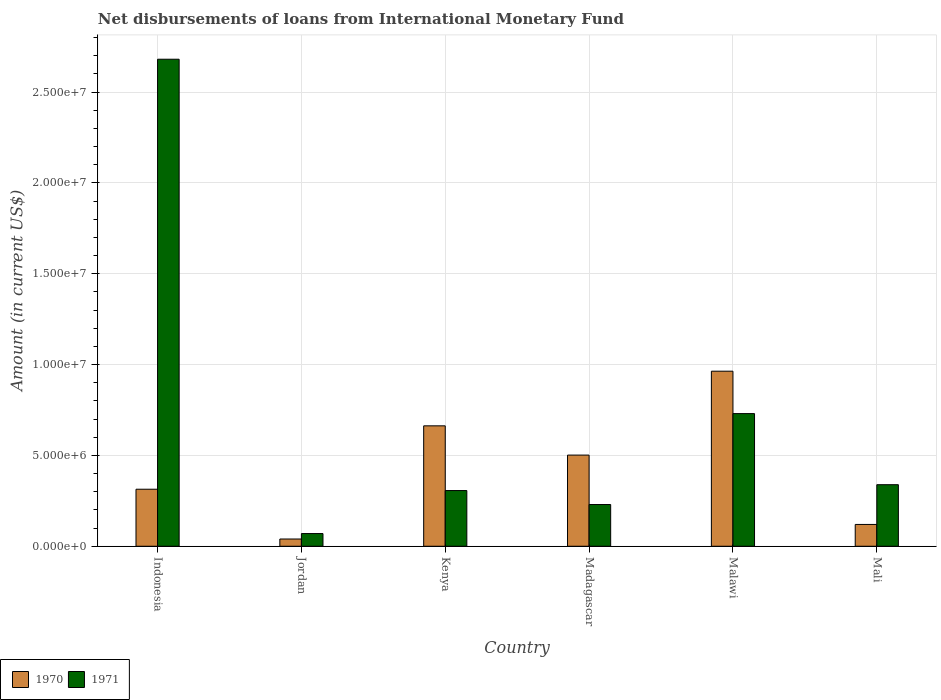How many groups of bars are there?
Your response must be concise. 6. Are the number of bars per tick equal to the number of legend labels?
Provide a succinct answer. Yes. How many bars are there on the 6th tick from the left?
Your response must be concise. 2. How many bars are there on the 1st tick from the right?
Your answer should be very brief. 2. What is the label of the 1st group of bars from the left?
Your answer should be compact. Indonesia. What is the amount of loans disbursed in 1971 in Indonesia?
Keep it short and to the point. 2.68e+07. Across all countries, what is the maximum amount of loans disbursed in 1971?
Provide a short and direct response. 2.68e+07. Across all countries, what is the minimum amount of loans disbursed in 1971?
Offer a very short reply. 6.99e+05. In which country was the amount of loans disbursed in 1970 maximum?
Your answer should be compact. Malawi. In which country was the amount of loans disbursed in 1970 minimum?
Your answer should be compact. Jordan. What is the total amount of loans disbursed in 1971 in the graph?
Make the answer very short. 4.36e+07. What is the difference between the amount of loans disbursed in 1971 in Jordan and that in Kenya?
Offer a very short reply. -2.37e+06. What is the difference between the amount of loans disbursed in 1971 in Malawi and the amount of loans disbursed in 1970 in Jordan?
Provide a short and direct response. 6.90e+06. What is the average amount of loans disbursed in 1971 per country?
Provide a succinct answer. 7.26e+06. What is the difference between the amount of loans disbursed of/in 1970 and amount of loans disbursed of/in 1971 in Kenya?
Offer a very short reply. 3.56e+06. What is the ratio of the amount of loans disbursed in 1971 in Kenya to that in Mali?
Provide a succinct answer. 0.9. What is the difference between the highest and the second highest amount of loans disbursed in 1971?
Provide a succinct answer. 2.34e+07. What is the difference between the highest and the lowest amount of loans disbursed in 1970?
Your answer should be compact. 9.24e+06. Is the sum of the amount of loans disbursed in 1970 in Malawi and Mali greater than the maximum amount of loans disbursed in 1971 across all countries?
Your response must be concise. No. Are all the bars in the graph horizontal?
Your answer should be very brief. No. How many countries are there in the graph?
Ensure brevity in your answer.  6. Are the values on the major ticks of Y-axis written in scientific E-notation?
Give a very brief answer. Yes. Where does the legend appear in the graph?
Ensure brevity in your answer.  Bottom left. How are the legend labels stacked?
Your answer should be very brief. Horizontal. What is the title of the graph?
Keep it short and to the point. Net disbursements of loans from International Monetary Fund. Does "1980" appear as one of the legend labels in the graph?
Ensure brevity in your answer.  No. What is the label or title of the X-axis?
Make the answer very short. Country. What is the label or title of the Y-axis?
Give a very brief answer. Amount (in current US$). What is the Amount (in current US$) of 1970 in Indonesia?
Your answer should be compact. 3.14e+06. What is the Amount (in current US$) of 1971 in Indonesia?
Make the answer very short. 2.68e+07. What is the Amount (in current US$) in 1970 in Jordan?
Your response must be concise. 3.99e+05. What is the Amount (in current US$) in 1971 in Jordan?
Offer a terse response. 6.99e+05. What is the Amount (in current US$) in 1970 in Kenya?
Your answer should be compact. 6.63e+06. What is the Amount (in current US$) of 1971 in Kenya?
Ensure brevity in your answer.  3.07e+06. What is the Amount (in current US$) of 1970 in Madagascar?
Ensure brevity in your answer.  5.02e+06. What is the Amount (in current US$) in 1971 in Madagascar?
Your answer should be very brief. 2.30e+06. What is the Amount (in current US$) of 1970 in Malawi?
Provide a short and direct response. 9.64e+06. What is the Amount (in current US$) in 1971 in Malawi?
Ensure brevity in your answer.  7.30e+06. What is the Amount (in current US$) of 1970 in Mali?
Your answer should be very brief. 1.20e+06. What is the Amount (in current US$) in 1971 in Mali?
Offer a very short reply. 3.39e+06. Across all countries, what is the maximum Amount (in current US$) in 1970?
Your answer should be compact. 9.64e+06. Across all countries, what is the maximum Amount (in current US$) of 1971?
Make the answer very short. 2.68e+07. Across all countries, what is the minimum Amount (in current US$) in 1970?
Your answer should be very brief. 3.99e+05. Across all countries, what is the minimum Amount (in current US$) in 1971?
Give a very brief answer. 6.99e+05. What is the total Amount (in current US$) of 1970 in the graph?
Your answer should be very brief. 2.60e+07. What is the total Amount (in current US$) in 1971 in the graph?
Provide a succinct answer. 4.36e+07. What is the difference between the Amount (in current US$) in 1970 in Indonesia and that in Jordan?
Offer a very short reply. 2.74e+06. What is the difference between the Amount (in current US$) in 1971 in Indonesia and that in Jordan?
Your answer should be compact. 2.61e+07. What is the difference between the Amount (in current US$) in 1970 in Indonesia and that in Kenya?
Give a very brief answer. -3.49e+06. What is the difference between the Amount (in current US$) in 1971 in Indonesia and that in Kenya?
Offer a terse response. 2.37e+07. What is the difference between the Amount (in current US$) of 1970 in Indonesia and that in Madagascar?
Provide a short and direct response. -1.88e+06. What is the difference between the Amount (in current US$) in 1971 in Indonesia and that in Madagascar?
Provide a succinct answer. 2.45e+07. What is the difference between the Amount (in current US$) in 1970 in Indonesia and that in Malawi?
Offer a very short reply. -6.50e+06. What is the difference between the Amount (in current US$) in 1971 in Indonesia and that in Malawi?
Offer a terse response. 1.95e+07. What is the difference between the Amount (in current US$) of 1970 in Indonesia and that in Mali?
Your answer should be very brief. 1.94e+06. What is the difference between the Amount (in current US$) of 1971 in Indonesia and that in Mali?
Your answer should be very brief. 2.34e+07. What is the difference between the Amount (in current US$) of 1970 in Jordan and that in Kenya?
Keep it short and to the point. -6.23e+06. What is the difference between the Amount (in current US$) in 1971 in Jordan and that in Kenya?
Your answer should be compact. -2.37e+06. What is the difference between the Amount (in current US$) of 1970 in Jordan and that in Madagascar?
Keep it short and to the point. -4.62e+06. What is the difference between the Amount (in current US$) in 1971 in Jordan and that in Madagascar?
Your answer should be compact. -1.60e+06. What is the difference between the Amount (in current US$) in 1970 in Jordan and that in Malawi?
Your answer should be compact. -9.24e+06. What is the difference between the Amount (in current US$) in 1971 in Jordan and that in Malawi?
Your response must be concise. -6.60e+06. What is the difference between the Amount (in current US$) of 1970 in Jordan and that in Mali?
Offer a very short reply. -8.01e+05. What is the difference between the Amount (in current US$) in 1971 in Jordan and that in Mali?
Offer a very short reply. -2.69e+06. What is the difference between the Amount (in current US$) of 1970 in Kenya and that in Madagascar?
Your answer should be very brief. 1.61e+06. What is the difference between the Amount (in current US$) in 1971 in Kenya and that in Madagascar?
Provide a short and direct response. 7.69e+05. What is the difference between the Amount (in current US$) of 1970 in Kenya and that in Malawi?
Ensure brevity in your answer.  -3.01e+06. What is the difference between the Amount (in current US$) in 1971 in Kenya and that in Malawi?
Keep it short and to the point. -4.24e+06. What is the difference between the Amount (in current US$) in 1970 in Kenya and that in Mali?
Provide a succinct answer. 5.43e+06. What is the difference between the Amount (in current US$) of 1971 in Kenya and that in Mali?
Your response must be concise. -3.22e+05. What is the difference between the Amount (in current US$) in 1970 in Madagascar and that in Malawi?
Your response must be concise. -4.62e+06. What is the difference between the Amount (in current US$) of 1971 in Madagascar and that in Malawi?
Make the answer very short. -5.00e+06. What is the difference between the Amount (in current US$) of 1970 in Madagascar and that in Mali?
Your answer should be very brief. 3.82e+06. What is the difference between the Amount (in current US$) of 1971 in Madagascar and that in Mali?
Your answer should be compact. -1.09e+06. What is the difference between the Amount (in current US$) of 1970 in Malawi and that in Mali?
Offer a terse response. 8.44e+06. What is the difference between the Amount (in current US$) in 1971 in Malawi and that in Mali?
Make the answer very short. 3.91e+06. What is the difference between the Amount (in current US$) in 1970 in Indonesia and the Amount (in current US$) in 1971 in Jordan?
Your response must be concise. 2.44e+06. What is the difference between the Amount (in current US$) of 1970 in Indonesia and the Amount (in current US$) of 1971 in Kenya?
Your answer should be very brief. 7.30e+04. What is the difference between the Amount (in current US$) in 1970 in Indonesia and the Amount (in current US$) in 1971 in Madagascar?
Your answer should be very brief. 8.42e+05. What is the difference between the Amount (in current US$) of 1970 in Indonesia and the Amount (in current US$) of 1971 in Malawi?
Give a very brief answer. -4.16e+06. What is the difference between the Amount (in current US$) of 1970 in Indonesia and the Amount (in current US$) of 1971 in Mali?
Provide a short and direct response. -2.49e+05. What is the difference between the Amount (in current US$) of 1970 in Jordan and the Amount (in current US$) of 1971 in Kenya?
Provide a short and direct response. -2.67e+06. What is the difference between the Amount (in current US$) of 1970 in Jordan and the Amount (in current US$) of 1971 in Madagascar?
Ensure brevity in your answer.  -1.90e+06. What is the difference between the Amount (in current US$) of 1970 in Jordan and the Amount (in current US$) of 1971 in Malawi?
Provide a short and direct response. -6.90e+06. What is the difference between the Amount (in current US$) in 1970 in Jordan and the Amount (in current US$) in 1971 in Mali?
Your answer should be compact. -2.99e+06. What is the difference between the Amount (in current US$) of 1970 in Kenya and the Amount (in current US$) of 1971 in Madagascar?
Offer a very short reply. 4.33e+06. What is the difference between the Amount (in current US$) in 1970 in Kenya and the Amount (in current US$) in 1971 in Malawi?
Give a very brief answer. -6.74e+05. What is the difference between the Amount (in current US$) of 1970 in Kenya and the Amount (in current US$) of 1971 in Mali?
Ensure brevity in your answer.  3.24e+06. What is the difference between the Amount (in current US$) in 1970 in Madagascar and the Amount (in current US$) in 1971 in Malawi?
Your response must be concise. -2.28e+06. What is the difference between the Amount (in current US$) of 1970 in Madagascar and the Amount (in current US$) of 1971 in Mali?
Your response must be concise. 1.63e+06. What is the difference between the Amount (in current US$) of 1970 in Malawi and the Amount (in current US$) of 1971 in Mali?
Your answer should be compact. 6.25e+06. What is the average Amount (in current US$) of 1970 per country?
Your response must be concise. 4.34e+06. What is the average Amount (in current US$) of 1971 per country?
Your response must be concise. 7.26e+06. What is the difference between the Amount (in current US$) in 1970 and Amount (in current US$) in 1971 in Indonesia?
Your answer should be very brief. -2.37e+07. What is the difference between the Amount (in current US$) in 1970 and Amount (in current US$) in 1971 in Jordan?
Your response must be concise. -3.00e+05. What is the difference between the Amount (in current US$) of 1970 and Amount (in current US$) of 1971 in Kenya?
Your answer should be compact. 3.56e+06. What is the difference between the Amount (in current US$) in 1970 and Amount (in current US$) in 1971 in Madagascar?
Offer a very short reply. 2.72e+06. What is the difference between the Amount (in current US$) of 1970 and Amount (in current US$) of 1971 in Malawi?
Give a very brief answer. 2.33e+06. What is the difference between the Amount (in current US$) of 1970 and Amount (in current US$) of 1971 in Mali?
Ensure brevity in your answer.  -2.19e+06. What is the ratio of the Amount (in current US$) of 1970 in Indonesia to that in Jordan?
Give a very brief answer. 7.87. What is the ratio of the Amount (in current US$) of 1971 in Indonesia to that in Jordan?
Your response must be concise. 38.35. What is the ratio of the Amount (in current US$) of 1970 in Indonesia to that in Kenya?
Offer a terse response. 0.47. What is the ratio of the Amount (in current US$) in 1971 in Indonesia to that in Kenya?
Your answer should be very brief. 8.74. What is the ratio of the Amount (in current US$) in 1970 in Indonesia to that in Madagascar?
Give a very brief answer. 0.63. What is the ratio of the Amount (in current US$) of 1971 in Indonesia to that in Madagascar?
Make the answer very short. 11.67. What is the ratio of the Amount (in current US$) in 1970 in Indonesia to that in Malawi?
Provide a succinct answer. 0.33. What is the ratio of the Amount (in current US$) in 1971 in Indonesia to that in Malawi?
Your answer should be very brief. 3.67. What is the ratio of the Amount (in current US$) of 1970 in Indonesia to that in Mali?
Provide a short and direct response. 2.62. What is the ratio of the Amount (in current US$) in 1971 in Indonesia to that in Mali?
Ensure brevity in your answer.  7.91. What is the ratio of the Amount (in current US$) in 1970 in Jordan to that in Kenya?
Make the answer very short. 0.06. What is the ratio of the Amount (in current US$) in 1971 in Jordan to that in Kenya?
Provide a short and direct response. 0.23. What is the ratio of the Amount (in current US$) in 1970 in Jordan to that in Madagascar?
Your answer should be very brief. 0.08. What is the ratio of the Amount (in current US$) of 1971 in Jordan to that in Madagascar?
Your answer should be compact. 0.3. What is the ratio of the Amount (in current US$) in 1970 in Jordan to that in Malawi?
Your answer should be compact. 0.04. What is the ratio of the Amount (in current US$) in 1971 in Jordan to that in Malawi?
Keep it short and to the point. 0.1. What is the ratio of the Amount (in current US$) in 1970 in Jordan to that in Mali?
Ensure brevity in your answer.  0.33. What is the ratio of the Amount (in current US$) of 1971 in Jordan to that in Mali?
Provide a succinct answer. 0.21. What is the ratio of the Amount (in current US$) of 1970 in Kenya to that in Madagascar?
Offer a terse response. 1.32. What is the ratio of the Amount (in current US$) in 1971 in Kenya to that in Madagascar?
Give a very brief answer. 1.33. What is the ratio of the Amount (in current US$) in 1970 in Kenya to that in Malawi?
Your response must be concise. 0.69. What is the ratio of the Amount (in current US$) in 1971 in Kenya to that in Malawi?
Make the answer very short. 0.42. What is the ratio of the Amount (in current US$) in 1970 in Kenya to that in Mali?
Offer a very short reply. 5.52. What is the ratio of the Amount (in current US$) in 1971 in Kenya to that in Mali?
Make the answer very short. 0.91. What is the ratio of the Amount (in current US$) of 1970 in Madagascar to that in Malawi?
Give a very brief answer. 0.52. What is the ratio of the Amount (in current US$) in 1971 in Madagascar to that in Malawi?
Your response must be concise. 0.31. What is the ratio of the Amount (in current US$) in 1970 in Madagascar to that in Mali?
Your response must be concise. 4.18. What is the ratio of the Amount (in current US$) of 1971 in Madagascar to that in Mali?
Provide a short and direct response. 0.68. What is the ratio of the Amount (in current US$) in 1970 in Malawi to that in Mali?
Make the answer very short. 8.03. What is the ratio of the Amount (in current US$) of 1971 in Malawi to that in Mali?
Provide a succinct answer. 2.16. What is the difference between the highest and the second highest Amount (in current US$) in 1970?
Provide a succinct answer. 3.01e+06. What is the difference between the highest and the second highest Amount (in current US$) of 1971?
Keep it short and to the point. 1.95e+07. What is the difference between the highest and the lowest Amount (in current US$) of 1970?
Offer a terse response. 9.24e+06. What is the difference between the highest and the lowest Amount (in current US$) of 1971?
Ensure brevity in your answer.  2.61e+07. 